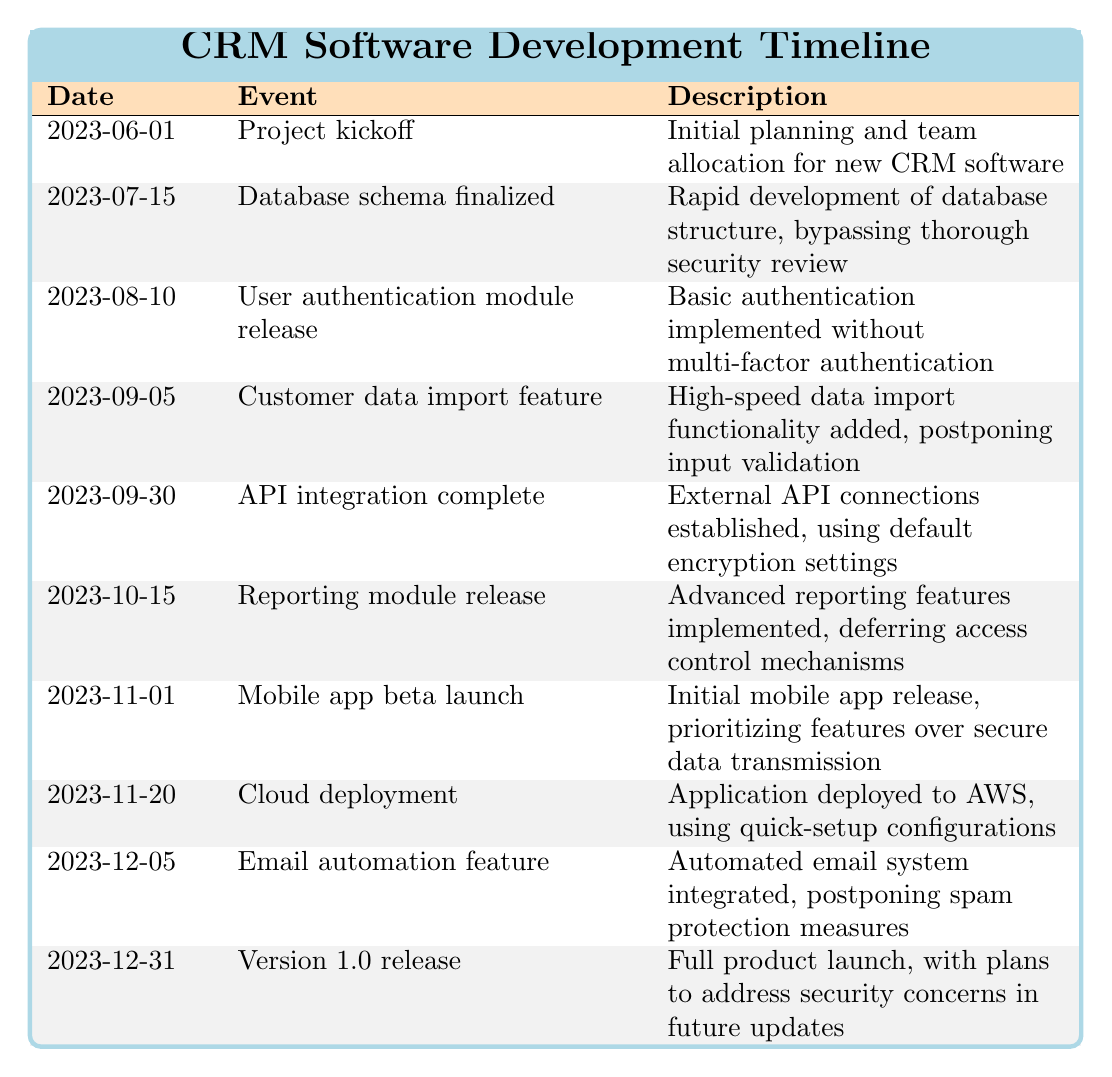What is the date of the project kickoff? The project kickoff event is listed under the date 2023-06-01 in the timeline table.
Answer: 2023-06-01 What event took place on October 15, 2023? The event scheduled for October 15, 2023, is the Reporting module release, as stated in the corresponding row of the table.
Answer: Reporting module release How many feature releases were planned before the Version 1.0 release? The table shows a total of 8 events before the Version 1.0 release on 2023-12-31; every event prior is considered a feature release or development milestone.
Answer: 8 Did the User authentication module release include multi-factor authentication? The description for the User authentication module release notes that it was implemented without multi-factor authentication, making this statement false.
Answer: No Which event was the first that mentioned any aspect of security? The first event mentioning security concerns was the Database schema finalized on 2023-07-15, specifically stating that thorough security review was bypassed.
Answer: Database schema finalized Was there any feature that prioritized functionality over security in its implementation? The table describes multiple features where security was deferred or postponed, such as the mobile app beta launch prioritizing features over secure data transmission, answering yes to this question.
Answer: Yes What is the average time between each event leading to the Version 1.0 release? To find the average time between events before the Version 1.0 release, calculate the spans between listed events from 2023-06-01 to 2023-12-31, totaling 6 months (or 183 days), divided by 9 intervals (8 releases plus kickoff), resulting in an average of approximately 20.33 days per interval.
Answer: Approximately 20.33 days On what date was the Cloud deployment event completed? The Cloud deployment event was noted to be completed on 2023-11-20, as mentioned in the relevant row of the table.
Answer: 2023-11-20 What was the last event before releasing the mobile app beta? The last event prior to the mobile app beta launch was the Reporting module release on 2023-10-15, which showcases the chronological progression of features leading to the beta.
Answer: Reporting module release 